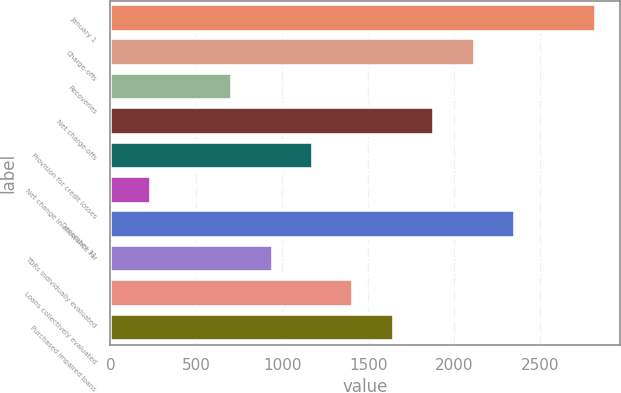Convert chart to OTSL. <chart><loc_0><loc_0><loc_500><loc_500><bar_chart><fcel>January 1<fcel>Charge-offs<fcel>Recoveries<fcel>Net charge-offs<fcel>Provision for credit losses<fcel>Net change in allowance for<fcel>December 31<fcel>TDRs individually evaluated<fcel>Loans collectively evaluated<fcel>Purchased impaired loans<nl><fcel>2821.86<fcel>2117.13<fcel>707.67<fcel>1882.22<fcel>1177.49<fcel>237.85<fcel>2352.04<fcel>942.58<fcel>1412.4<fcel>1647.31<nl></chart> 